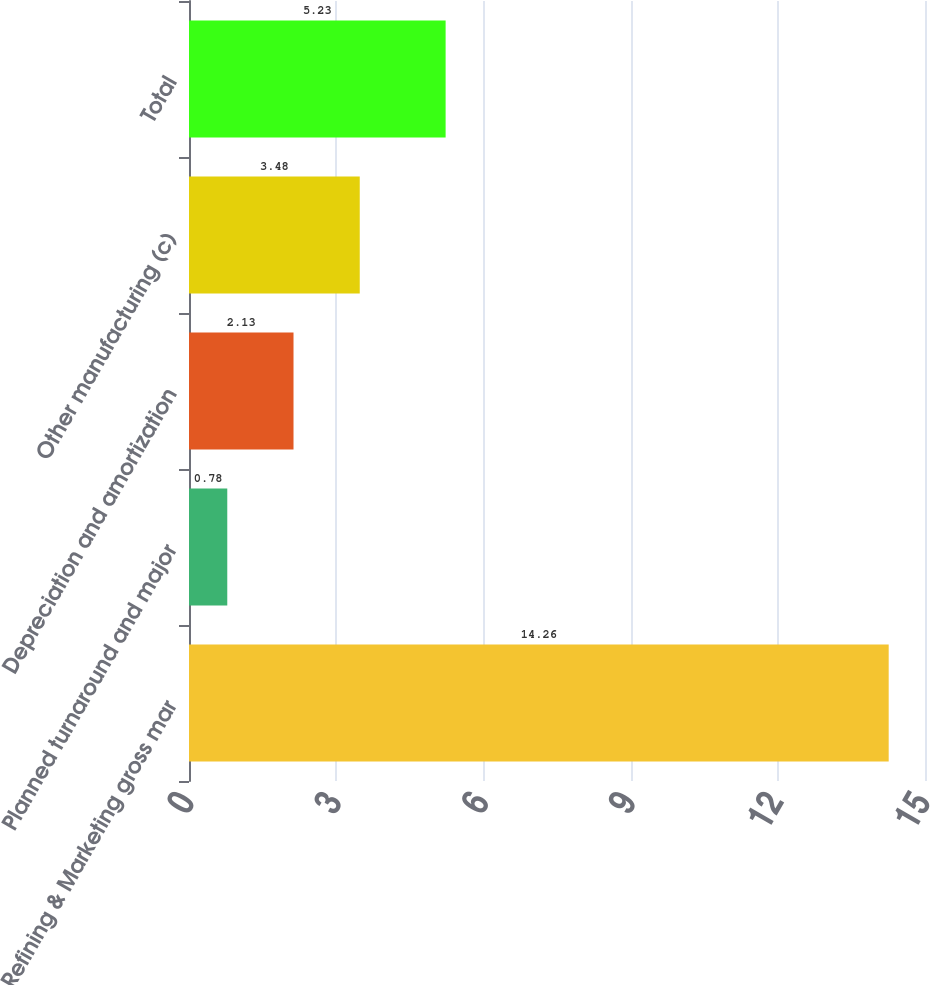Convert chart to OTSL. <chart><loc_0><loc_0><loc_500><loc_500><bar_chart><fcel>Refining & Marketing gross mar<fcel>Planned turnaround and major<fcel>Depreciation and amortization<fcel>Other manufacturing (c)<fcel>Total<nl><fcel>14.26<fcel>0.78<fcel>2.13<fcel>3.48<fcel>5.23<nl></chart> 